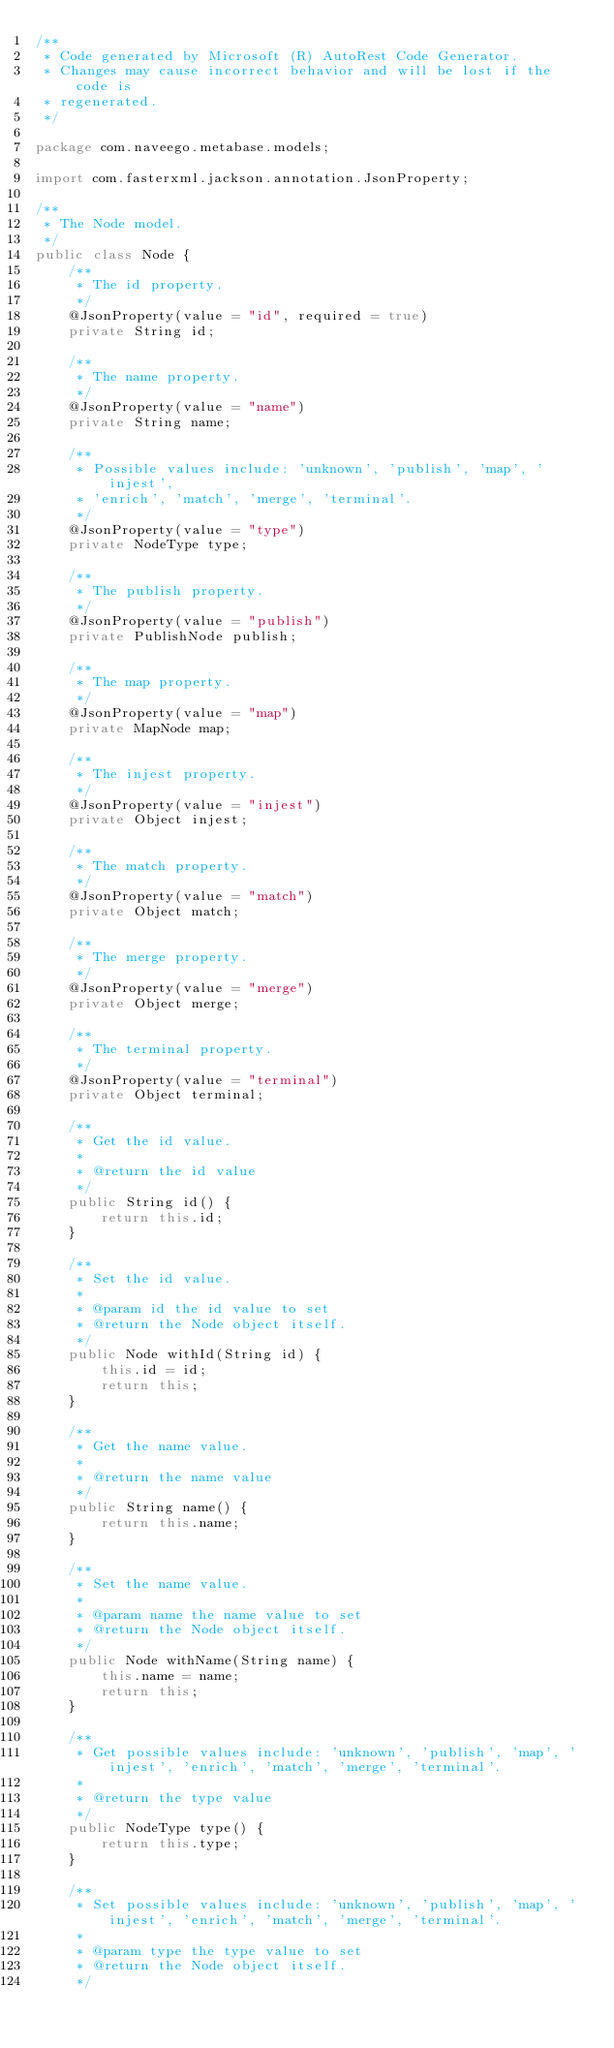Convert code to text. <code><loc_0><loc_0><loc_500><loc_500><_Java_>/**
 * Code generated by Microsoft (R) AutoRest Code Generator.
 * Changes may cause incorrect behavior and will be lost if the code is
 * regenerated.
 */

package com.naveego.metabase.models;

import com.fasterxml.jackson.annotation.JsonProperty;

/**
 * The Node model.
 */
public class Node {
    /**
     * The id property.
     */
    @JsonProperty(value = "id", required = true)
    private String id;

    /**
     * The name property.
     */
    @JsonProperty(value = "name")
    private String name;

    /**
     * Possible values include: 'unknown', 'publish', 'map', 'injest',
     * 'enrich', 'match', 'merge', 'terminal'.
     */
    @JsonProperty(value = "type")
    private NodeType type;

    /**
     * The publish property.
     */
    @JsonProperty(value = "publish")
    private PublishNode publish;

    /**
     * The map property.
     */
    @JsonProperty(value = "map")
    private MapNode map;

    /**
     * The injest property.
     */
    @JsonProperty(value = "injest")
    private Object injest;

    /**
     * The match property.
     */
    @JsonProperty(value = "match")
    private Object match;

    /**
     * The merge property.
     */
    @JsonProperty(value = "merge")
    private Object merge;

    /**
     * The terminal property.
     */
    @JsonProperty(value = "terminal")
    private Object terminal;

    /**
     * Get the id value.
     *
     * @return the id value
     */
    public String id() {
        return this.id;
    }

    /**
     * Set the id value.
     *
     * @param id the id value to set
     * @return the Node object itself.
     */
    public Node withId(String id) {
        this.id = id;
        return this;
    }

    /**
     * Get the name value.
     *
     * @return the name value
     */
    public String name() {
        return this.name;
    }

    /**
     * Set the name value.
     *
     * @param name the name value to set
     * @return the Node object itself.
     */
    public Node withName(String name) {
        this.name = name;
        return this;
    }

    /**
     * Get possible values include: 'unknown', 'publish', 'map', 'injest', 'enrich', 'match', 'merge', 'terminal'.
     *
     * @return the type value
     */
    public NodeType type() {
        return this.type;
    }

    /**
     * Set possible values include: 'unknown', 'publish', 'map', 'injest', 'enrich', 'match', 'merge', 'terminal'.
     *
     * @param type the type value to set
     * @return the Node object itself.
     */</code> 